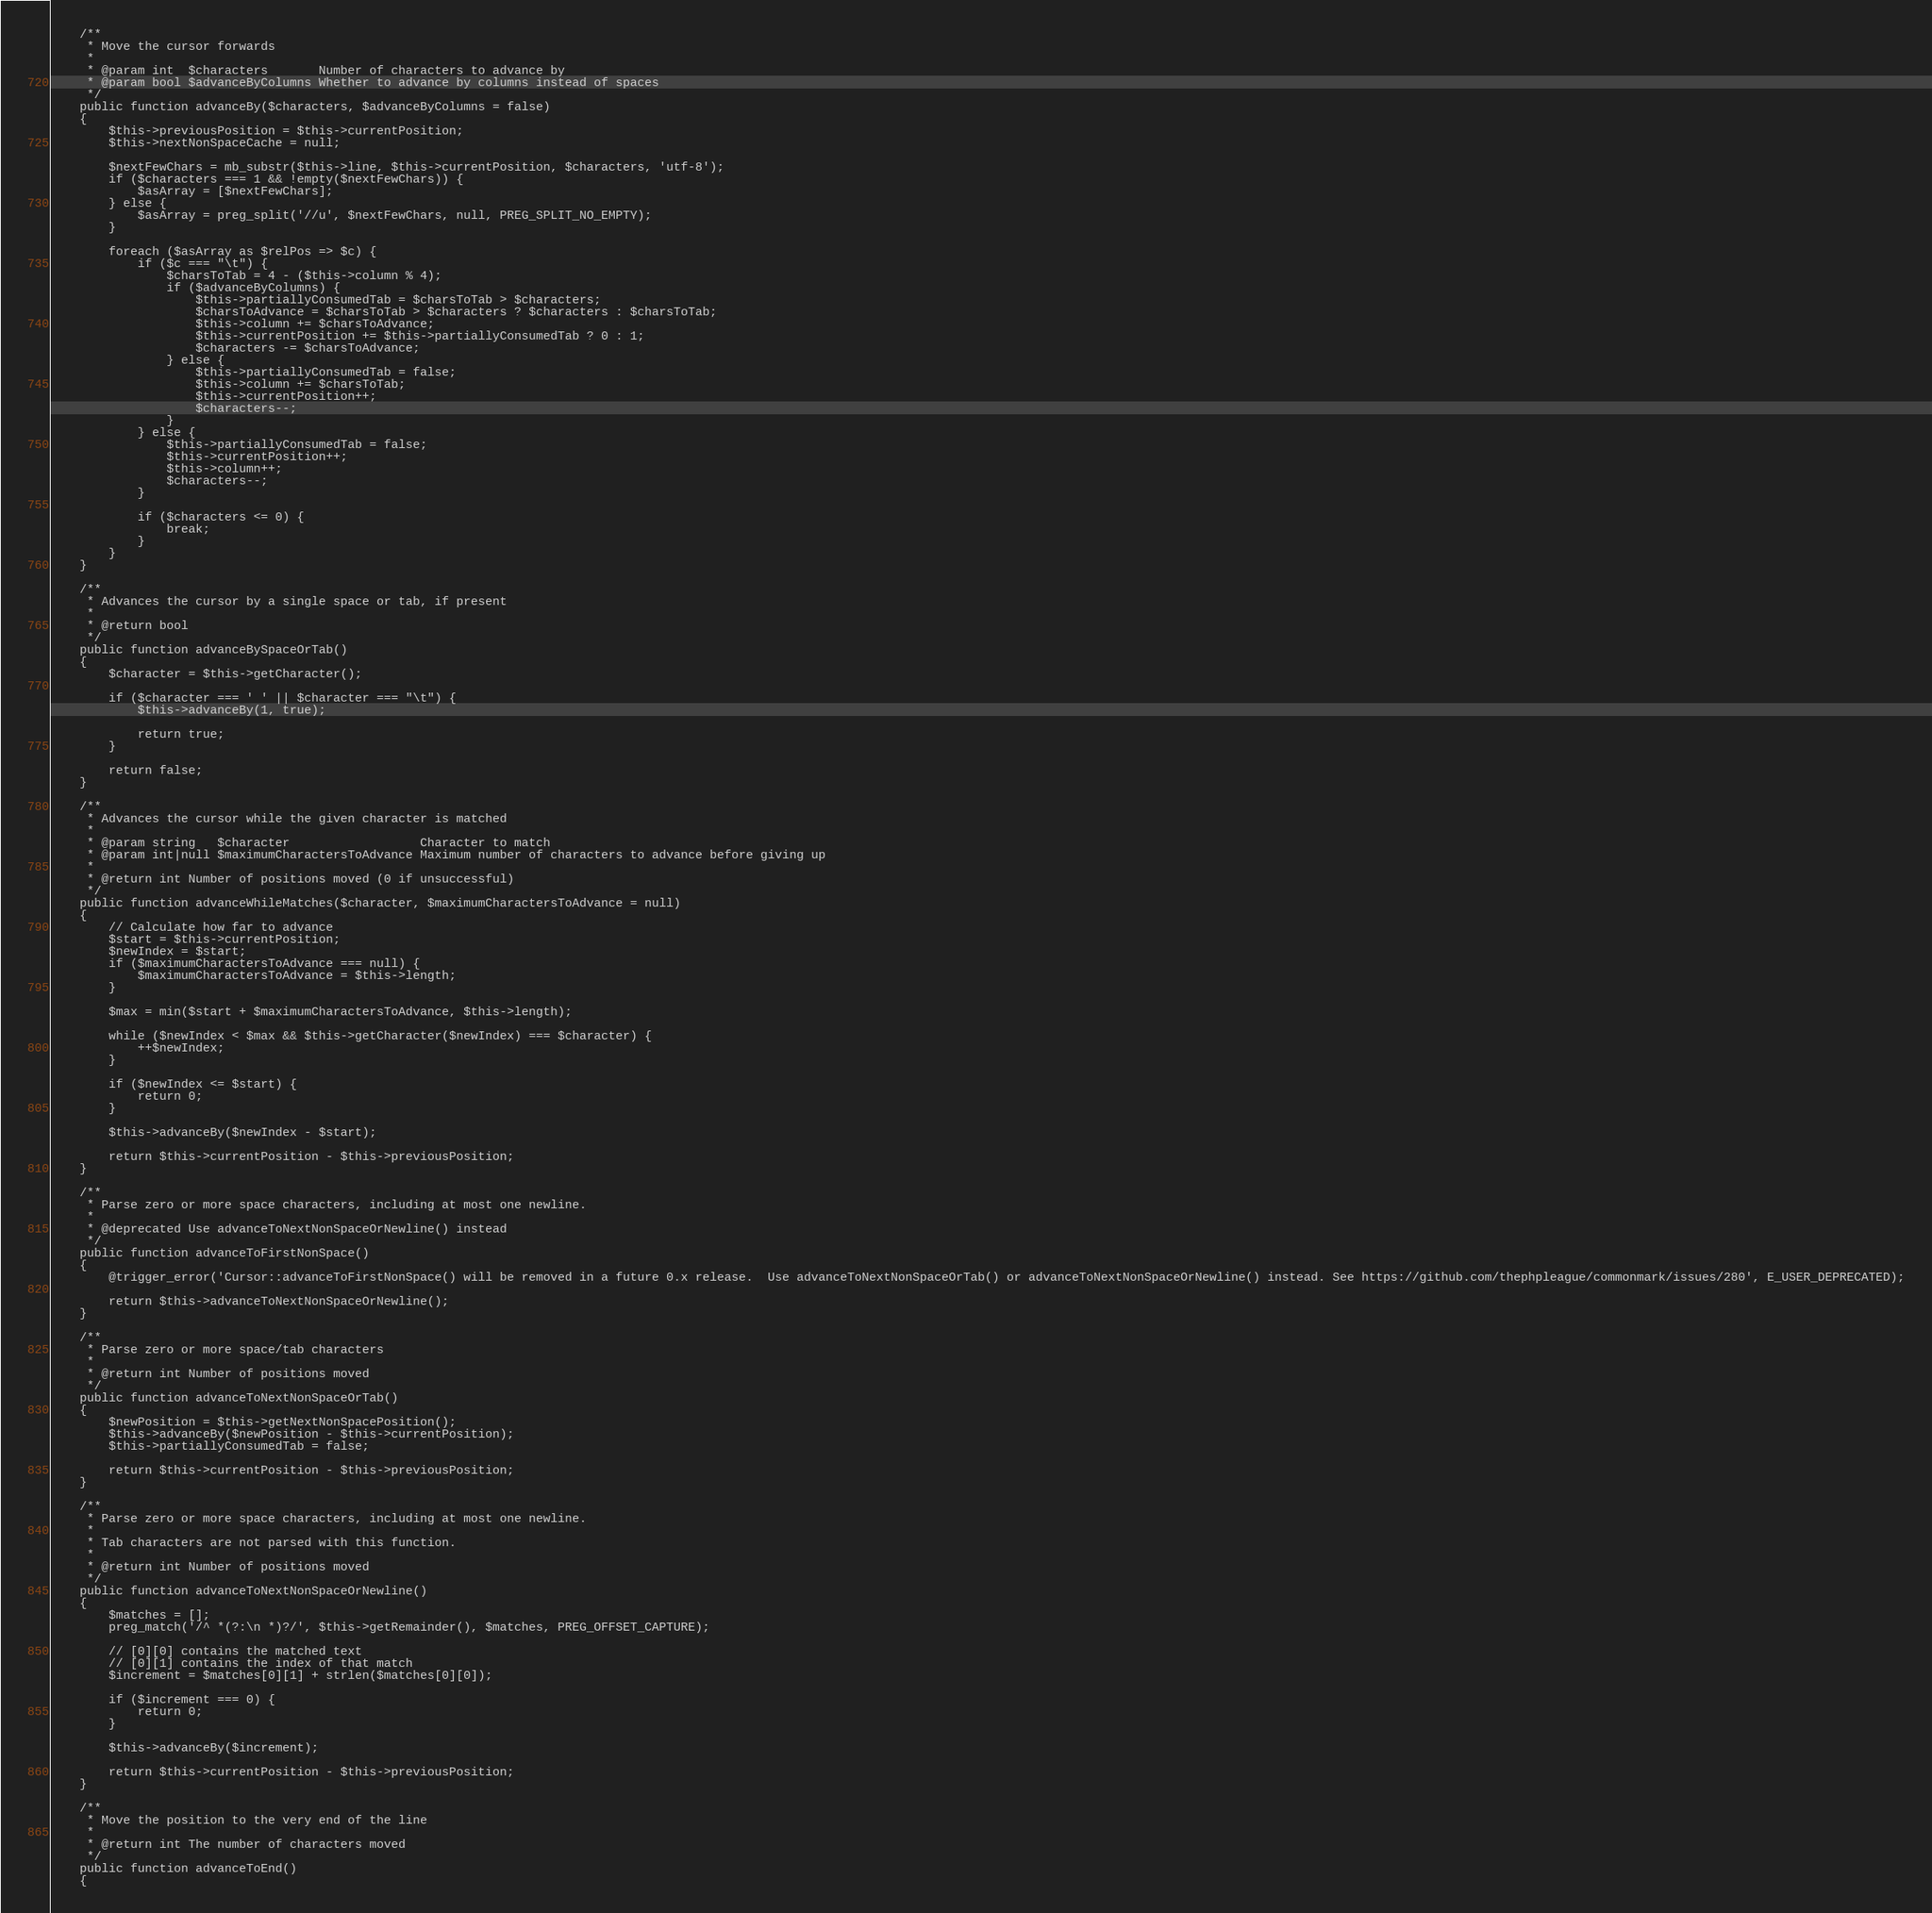<code> <loc_0><loc_0><loc_500><loc_500><_PHP_>    /**
     * Move the cursor forwards
     *
     * @param int  $characters       Number of characters to advance by
     * @param bool $advanceByColumns Whether to advance by columns instead of spaces
     */
    public function advanceBy($characters, $advanceByColumns = false)
    {
        $this->previousPosition = $this->currentPosition;
        $this->nextNonSpaceCache = null;

        $nextFewChars = mb_substr($this->line, $this->currentPosition, $characters, 'utf-8');
        if ($characters === 1 && !empty($nextFewChars)) {
            $asArray = [$nextFewChars];
        } else {
            $asArray = preg_split('//u', $nextFewChars, null, PREG_SPLIT_NO_EMPTY);
        }

        foreach ($asArray as $relPos => $c) {
            if ($c === "\t") {
                $charsToTab = 4 - ($this->column % 4);
                if ($advanceByColumns) {
                    $this->partiallyConsumedTab = $charsToTab > $characters;
                    $charsToAdvance = $charsToTab > $characters ? $characters : $charsToTab;
                    $this->column += $charsToAdvance;
                    $this->currentPosition += $this->partiallyConsumedTab ? 0 : 1;
                    $characters -= $charsToAdvance;
                } else {
                    $this->partiallyConsumedTab = false;
                    $this->column += $charsToTab;
                    $this->currentPosition++;
                    $characters--;
                }
            } else {
                $this->partiallyConsumedTab = false;
                $this->currentPosition++;
                $this->column++;
                $characters--;
            }

            if ($characters <= 0) {
                break;
            }
        }
    }

    /**
     * Advances the cursor by a single space or tab, if present
     *
     * @return bool
     */
    public function advanceBySpaceOrTab()
    {
        $character = $this->getCharacter();

        if ($character === ' ' || $character === "\t") {
            $this->advanceBy(1, true);

            return true;
        }

        return false;
    }

    /**
     * Advances the cursor while the given character is matched
     *
     * @param string   $character                  Character to match
     * @param int|null $maximumCharactersToAdvance Maximum number of characters to advance before giving up
     *
     * @return int Number of positions moved (0 if unsuccessful)
     */
    public function advanceWhileMatches($character, $maximumCharactersToAdvance = null)
    {
        // Calculate how far to advance
        $start = $this->currentPosition;
        $newIndex = $start;
        if ($maximumCharactersToAdvance === null) {
            $maximumCharactersToAdvance = $this->length;
        }

        $max = min($start + $maximumCharactersToAdvance, $this->length);

        while ($newIndex < $max && $this->getCharacter($newIndex) === $character) {
            ++$newIndex;
        }

        if ($newIndex <= $start) {
            return 0;
        }

        $this->advanceBy($newIndex - $start);

        return $this->currentPosition - $this->previousPosition;
    }

    /**
     * Parse zero or more space characters, including at most one newline.
     *
     * @deprecated Use advanceToNextNonSpaceOrNewline() instead
     */
    public function advanceToFirstNonSpace()
    {
        @trigger_error('Cursor::advanceToFirstNonSpace() will be removed in a future 0.x release.  Use advanceToNextNonSpaceOrTab() or advanceToNextNonSpaceOrNewline() instead. See https://github.com/thephpleague/commonmark/issues/280', E_USER_DEPRECATED);

        return $this->advanceToNextNonSpaceOrNewline();
    }

    /**
     * Parse zero or more space/tab characters
     *
     * @return int Number of positions moved
     */
    public function advanceToNextNonSpaceOrTab()
    {
        $newPosition = $this->getNextNonSpacePosition();
        $this->advanceBy($newPosition - $this->currentPosition);
        $this->partiallyConsumedTab = false;

        return $this->currentPosition - $this->previousPosition;
    }

    /**
     * Parse zero or more space characters, including at most one newline.
     *
     * Tab characters are not parsed with this function.
     *
     * @return int Number of positions moved
     */
    public function advanceToNextNonSpaceOrNewline()
    {
        $matches = [];
        preg_match('/^ *(?:\n *)?/', $this->getRemainder(), $matches, PREG_OFFSET_CAPTURE);

        // [0][0] contains the matched text
        // [0][1] contains the index of that match
        $increment = $matches[0][1] + strlen($matches[0][0]);

        if ($increment === 0) {
            return 0;
        }

        $this->advanceBy($increment);

        return $this->currentPosition - $this->previousPosition;
    }

    /**
     * Move the position to the very end of the line
     *
     * @return int The number of characters moved
     */
    public function advanceToEnd()
    {</code> 